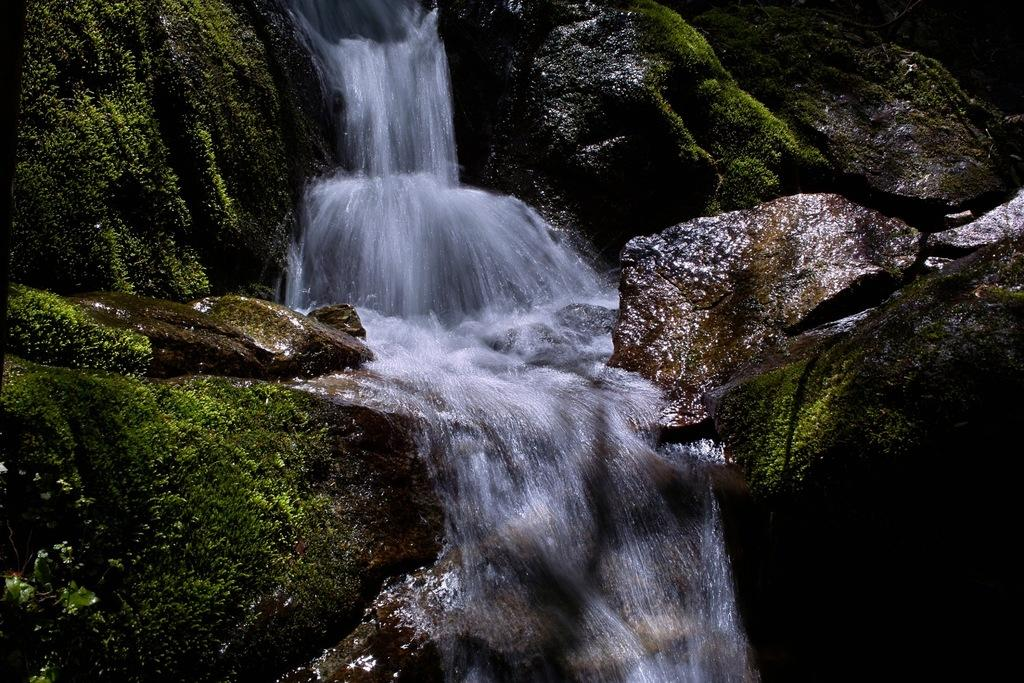What is the primary element visible in the image? There is water in the image. How is the water moving in the image? The water is flowing in the middle of the image. What other objects can be seen in the image? There are rocks in the image. Where is the trail leading to in the image? There is no trail present in the image; it only features water flowing and rocks. Can you see a fight happening between the rocks in the image? There is no fight happening between the rocks in the image; they are stationary objects. 